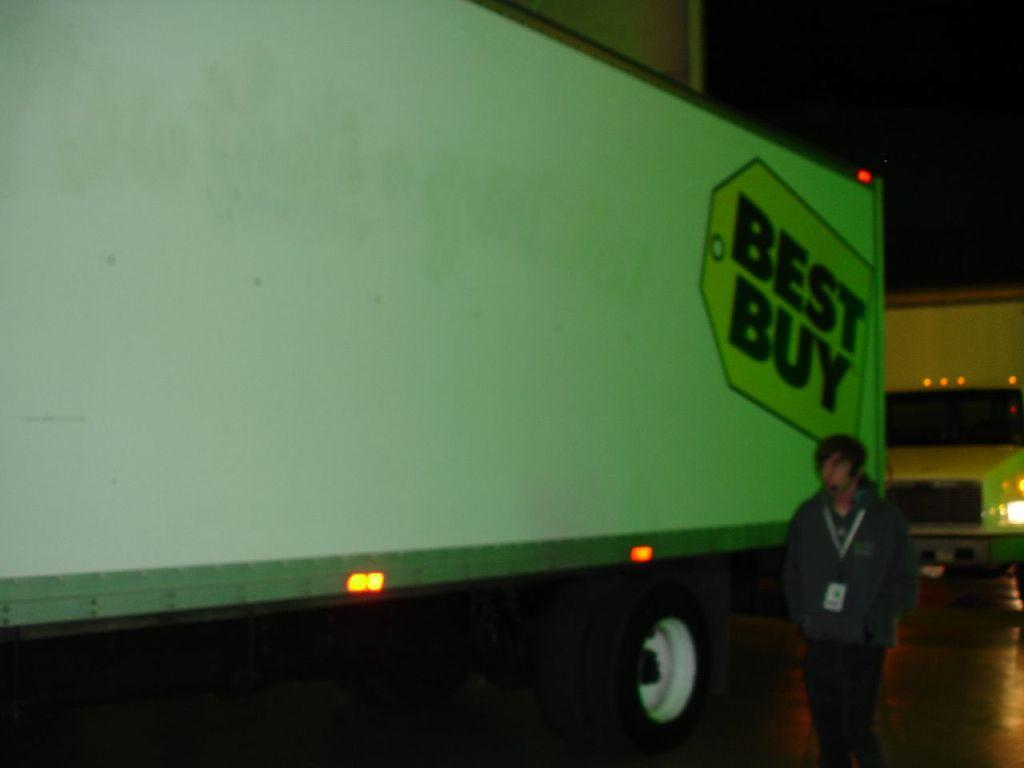What is the main subject of the image? There is a person standing in the image. What else can be seen in the image besides the person? There are vehicles in the image. What is the color of the sky in the background? The sky in the background appears to be black. Where is the honey stored in the image? There is no honey present in the image. Is the camera visible in the image? There is no camera visible in the image. 